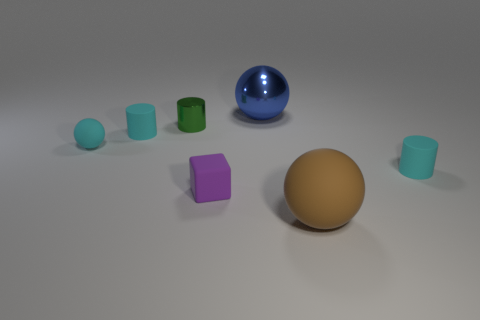Does the tiny rubber sphere have the same color as the cylinder left of the metallic cylinder?
Provide a succinct answer. Yes. Are there an equal number of small matte spheres on the right side of the blue metallic sphere and big blue metal things in front of the brown thing?
Provide a short and direct response. Yes. There is a matte cylinder that is behind the small cylinder in front of the small cyan cylinder on the left side of the purple matte cube; what color is it?
Your answer should be very brief. Cyan. How many small rubber objects are both left of the big rubber ball and on the right side of the large rubber sphere?
Provide a succinct answer. 0. There is a matte cylinder in front of the tiny cyan ball; is its color the same as the rubber cylinder that is on the left side of the large metal sphere?
Your answer should be very brief. Yes. What is the size of the other matte thing that is the same shape as the big brown rubber object?
Ensure brevity in your answer.  Small. There is a big brown ball; are there any small cyan things on the left side of it?
Keep it short and to the point. Yes. Are there the same number of cyan matte cylinders in front of the brown ball and big blue metal objects?
Give a very brief answer. No. Are there any rubber cylinders that are left of the small cyan matte cylinder on the right side of the tiny cyan cylinder that is on the left side of the purple block?
Ensure brevity in your answer.  Yes. What material is the cyan sphere?
Your response must be concise. Rubber. 